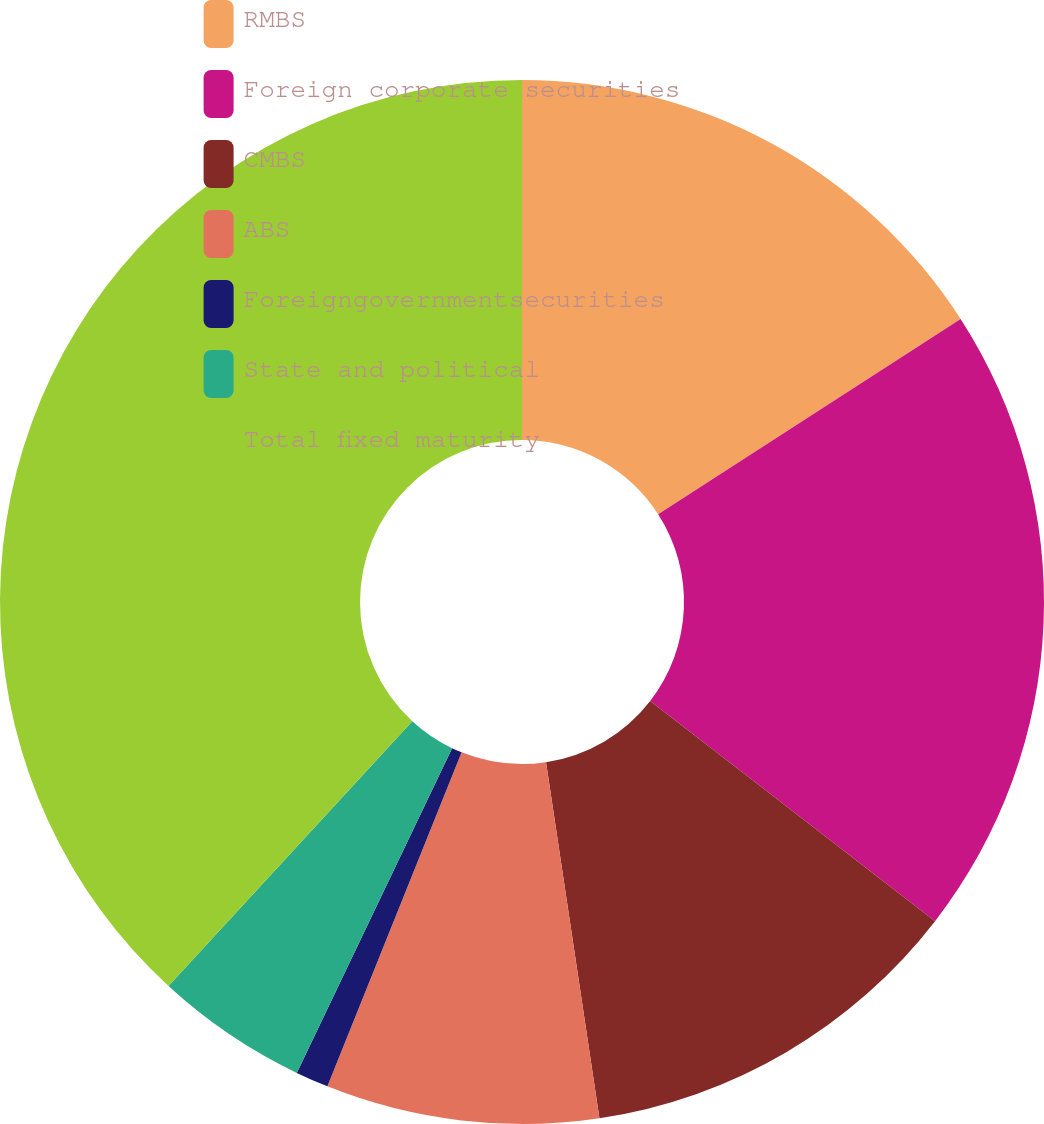Convert chart to OTSL. <chart><loc_0><loc_0><loc_500><loc_500><pie_chart><fcel>RMBS<fcel>Foreign corporate securities<fcel>CMBS<fcel>ABS<fcel>Foreigngovernmentsecurities<fcel>State and political<fcel>Total fixed maturity<nl><fcel>15.88%<fcel>19.59%<fcel>12.16%<fcel>8.45%<fcel>1.02%<fcel>4.74%<fcel>38.16%<nl></chart> 